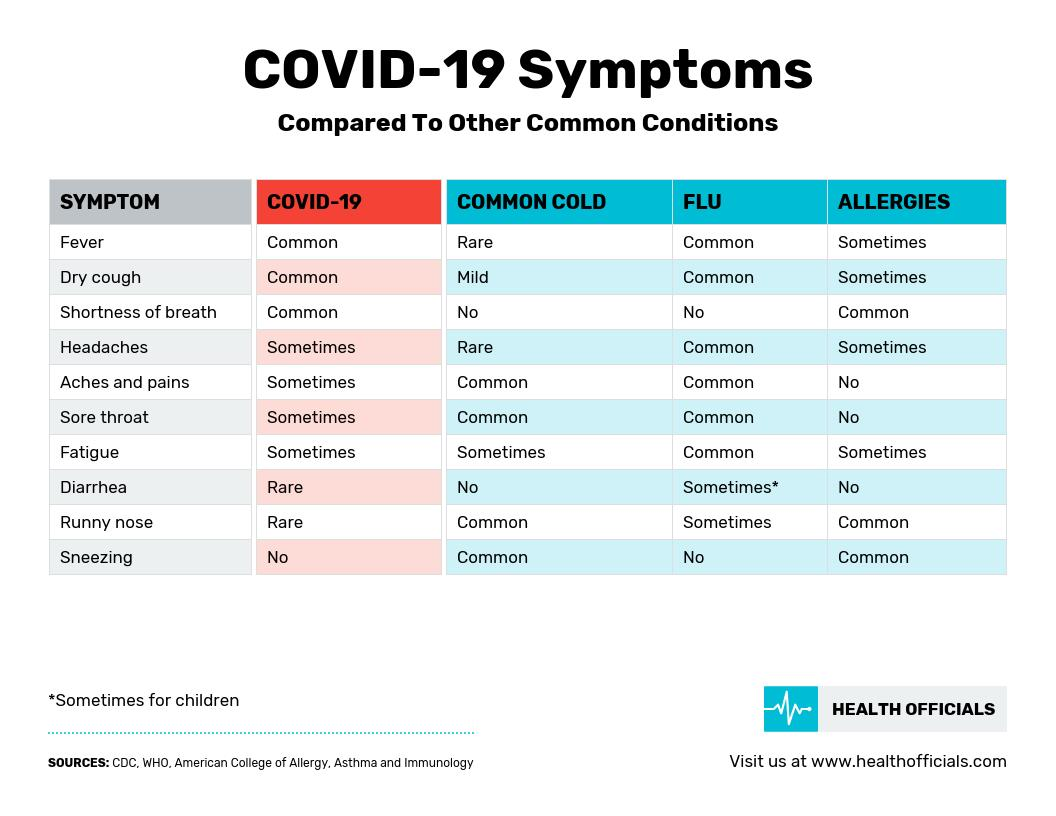Give some essential details in this illustration. COVID-19 and the flu are both respiratory illnesses that can cause common symptoms such as fever and a dry cough. The symptoms of the common cold that are considered rare are fever and headaches. Sneezing is not a symptom of both COVID-19 and the flu. Fatigue is a symptom that can occur sometimes for both COVID-19 and the common cold. COVID-19 can present with a variety of symptoms, but some are more uncommon than others. These include diarrhea and runny nose, which are less common than other symptoms such as fever, cough, and shortness of breath. 